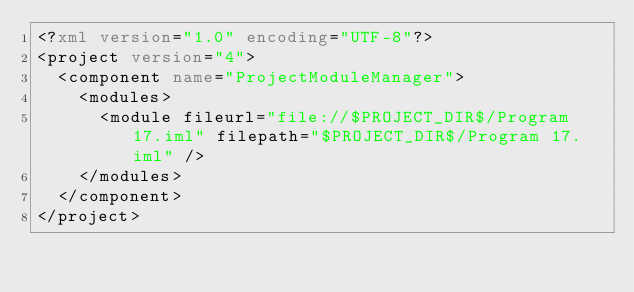<code> <loc_0><loc_0><loc_500><loc_500><_XML_><?xml version="1.0" encoding="UTF-8"?>
<project version="4">
  <component name="ProjectModuleManager">
    <modules>
      <module fileurl="file://$PROJECT_DIR$/Program 17.iml" filepath="$PROJECT_DIR$/Program 17.iml" />
    </modules>
  </component>
</project></code> 